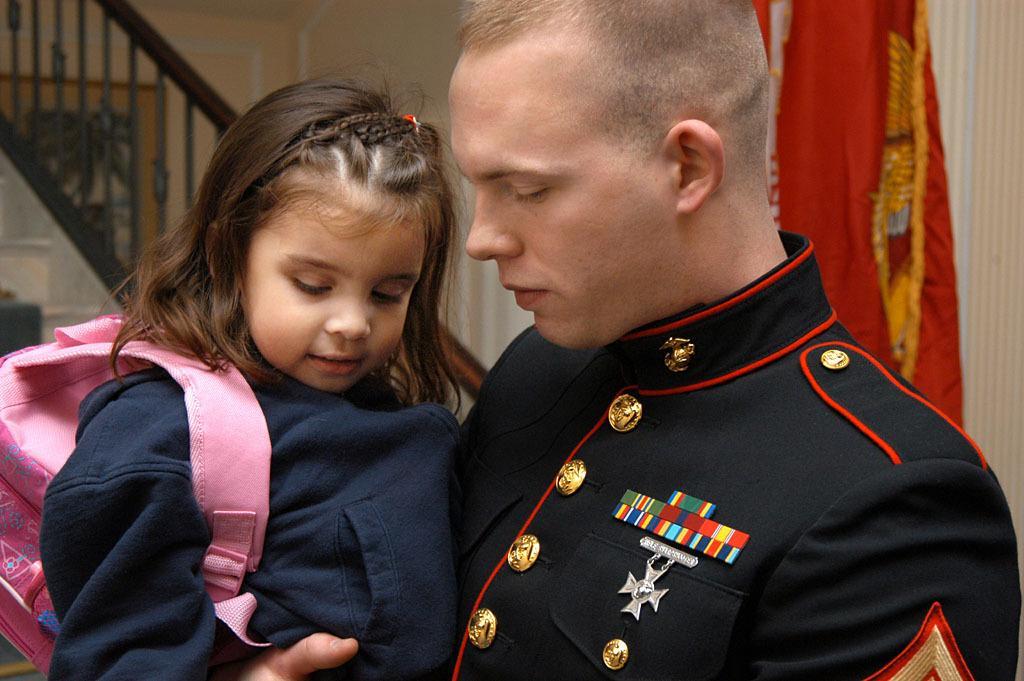Describe this image in one or two sentences. In the image a person is standing and holding a baby. Behind them there is a staircase and flag and wall. 